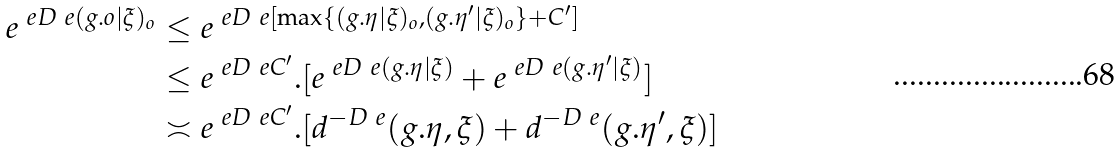<formula> <loc_0><loc_0><loc_500><loc_500>e ^ { \ e D _ { \ } e ( g . o | \xi ) _ { o } } & \leq e ^ { \ e D _ { \ } e [ \max \{ ( g . \eta | \xi ) _ { o } , ( g . \eta ^ { \prime } | \xi ) _ { o } \} + C ^ { \prime } ] } \\ & \leq e ^ { \ e D _ { \ } e C ^ { \prime } } . [ e ^ { \ e D _ { \ } e ( g . \eta | \xi ) } + e ^ { \ e D _ { \ } e ( g . \eta ^ { \prime } | \xi ) } ] \\ & \asymp e ^ { \ e D _ { \ } e C ^ { \prime } } . [ d ^ { - D _ { \ } e } ( g . \eta , \xi ) + d ^ { - D _ { \ } e } ( g . \eta ^ { \prime } , \xi ) ]</formula> 